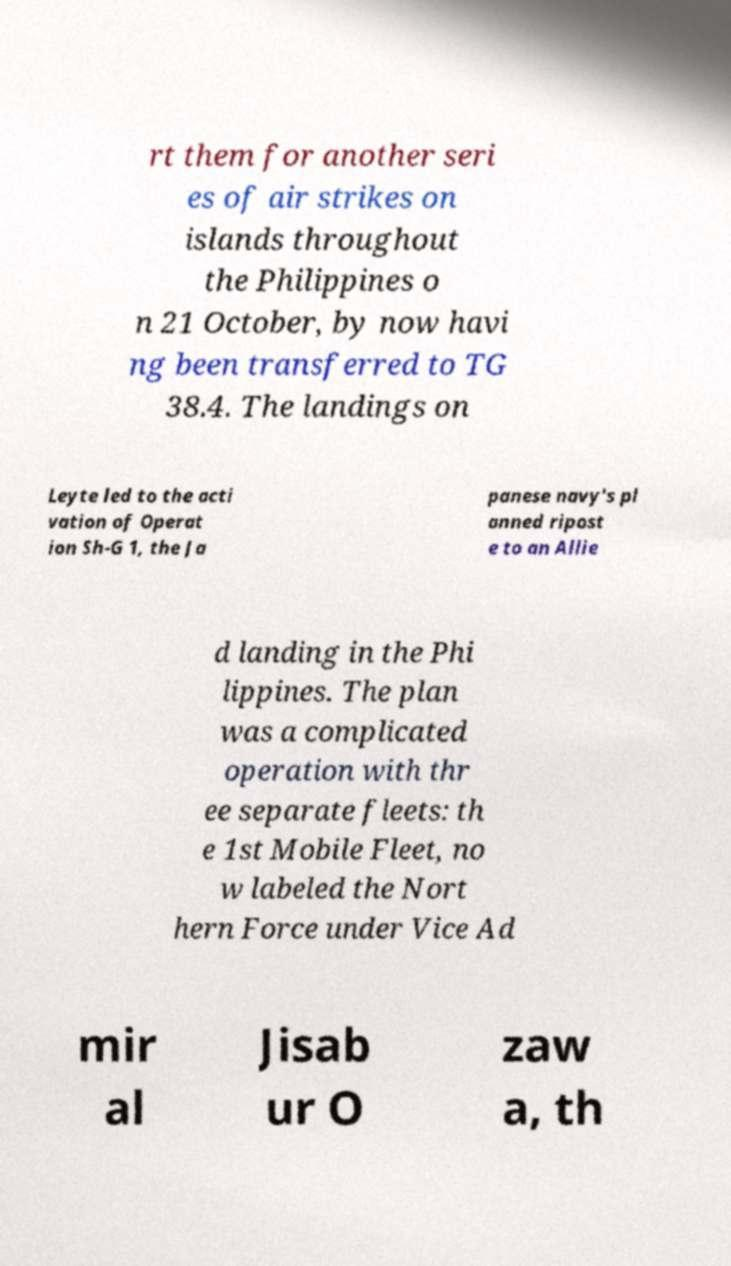Could you extract and type out the text from this image? rt them for another seri es of air strikes on islands throughout the Philippines o n 21 October, by now havi ng been transferred to TG 38.4. The landings on Leyte led to the acti vation of Operat ion Sh-G 1, the Ja panese navy's pl anned ripost e to an Allie d landing in the Phi lippines. The plan was a complicated operation with thr ee separate fleets: th e 1st Mobile Fleet, no w labeled the Nort hern Force under Vice Ad mir al Jisab ur O zaw a, th 